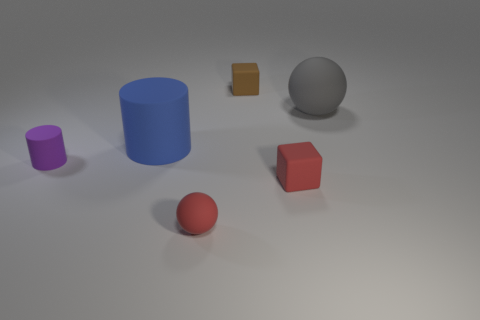Imagine this is a scene from a story. What relationship might these objects have to each other? It's as if each object represents a character in a tale of a diverse community. The different shapes and sizes symbolize their unique qualities and roles within their little universe, contributing to a harmonious balance. 